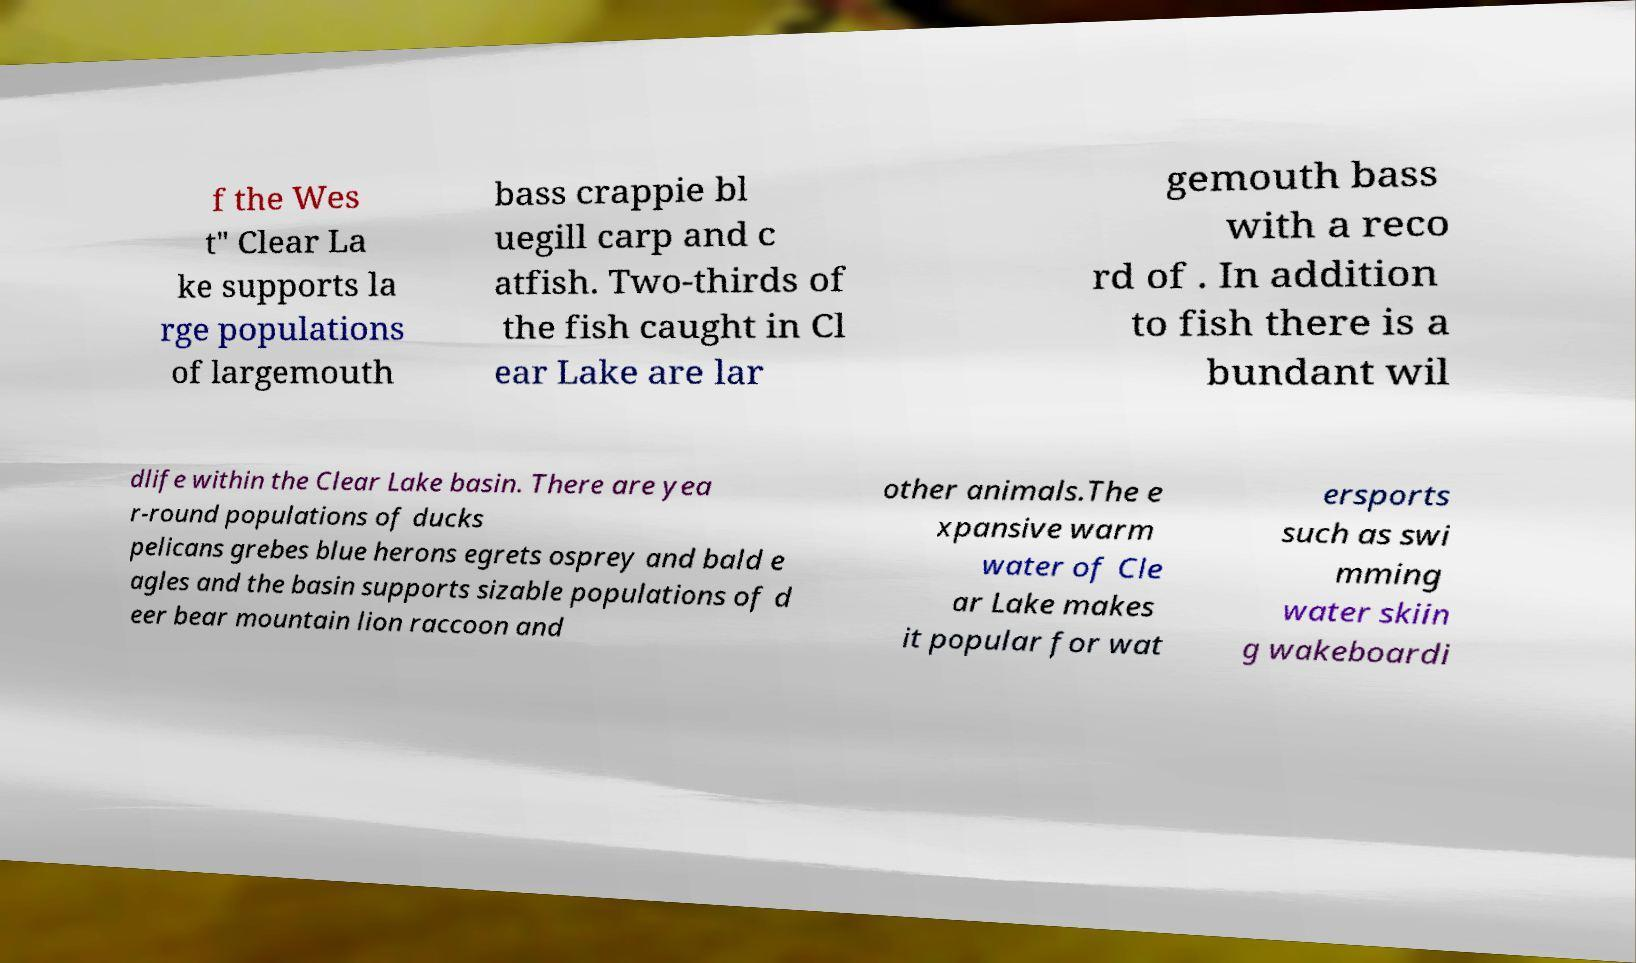Please read and relay the text visible in this image. What does it say? f the Wes t" Clear La ke supports la rge populations of largemouth bass crappie bl uegill carp and c atfish. Two-thirds of the fish caught in Cl ear Lake are lar gemouth bass with a reco rd of . In addition to fish there is a bundant wil dlife within the Clear Lake basin. There are yea r-round populations of ducks pelicans grebes blue herons egrets osprey and bald e agles and the basin supports sizable populations of d eer bear mountain lion raccoon and other animals.The e xpansive warm water of Cle ar Lake makes it popular for wat ersports such as swi mming water skiin g wakeboardi 